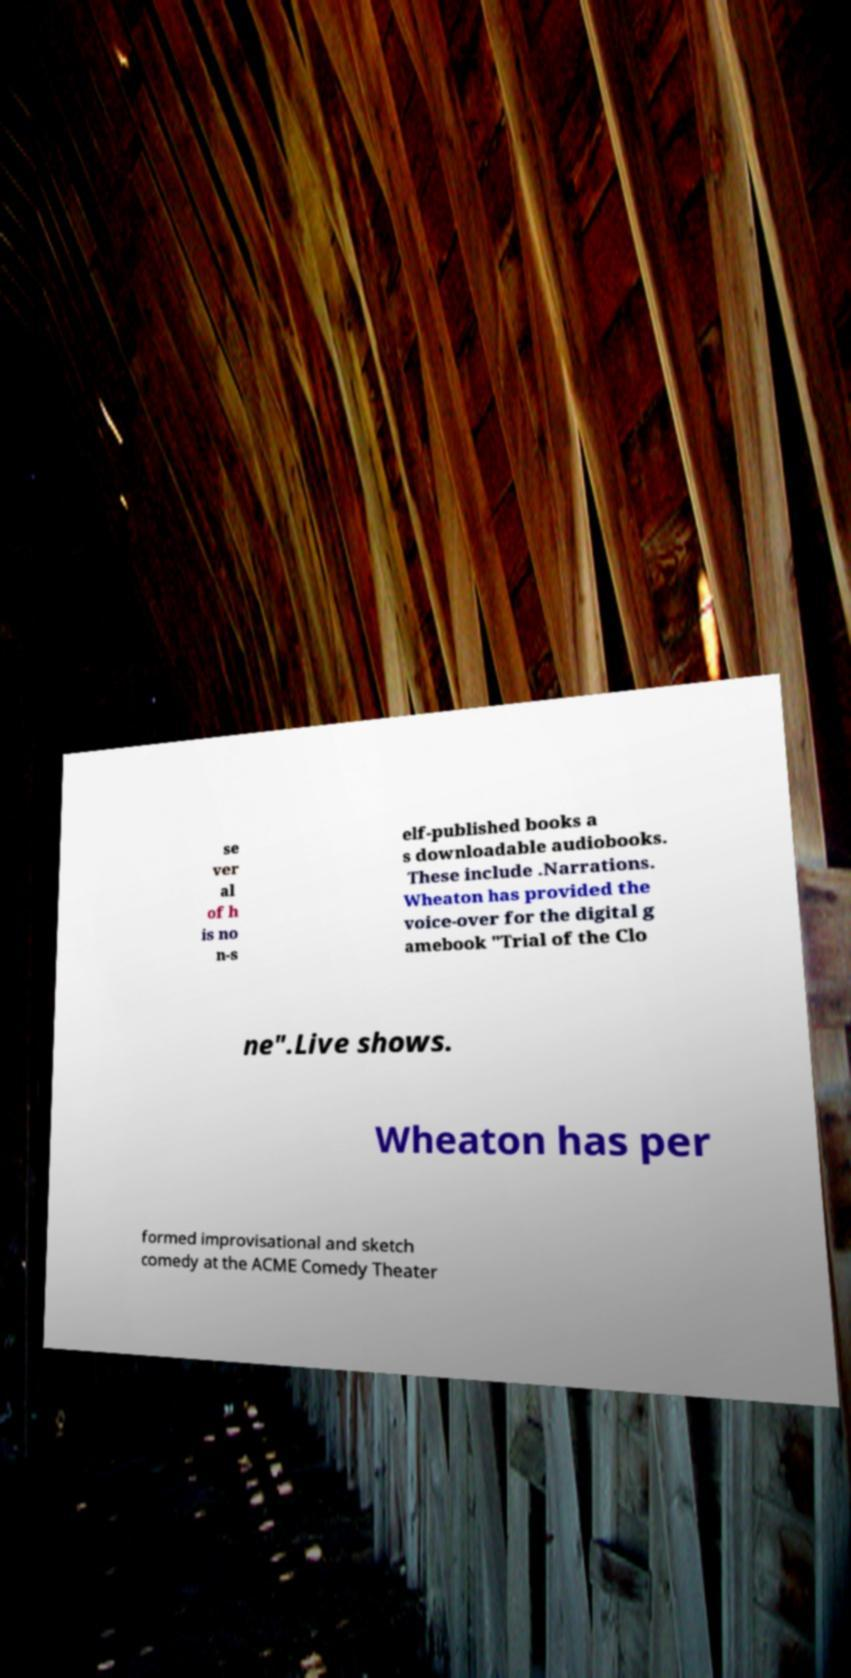I need the written content from this picture converted into text. Can you do that? se ver al of h is no n-s elf-published books a s downloadable audiobooks. These include .Narrations. Wheaton has provided the voice-over for the digital g amebook "Trial of the Clo ne".Live shows. Wheaton has per formed improvisational and sketch comedy at the ACME Comedy Theater 